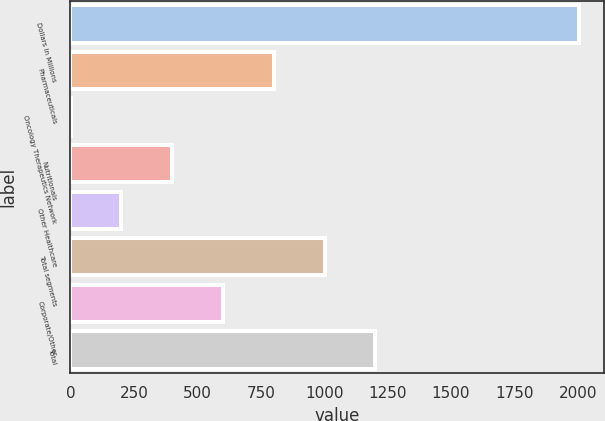<chart> <loc_0><loc_0><loc_500><loc_500><bar_chart><fcel>Dollars in Millions<fcel>Pharmaceuticals<fcel>Oncology Therapeutics Network<fcel>Nutritionals<fcel>Other Healthcare<fcel>Total segments<fcel>Corporate/Other<fcel>Total<nl><fcel>2003<fcel>801.8<fcel>1<fcel>401.4<fcel>201.2<fcel>1002<fcel>601.6<fcel>1202.2<nl></chart> 